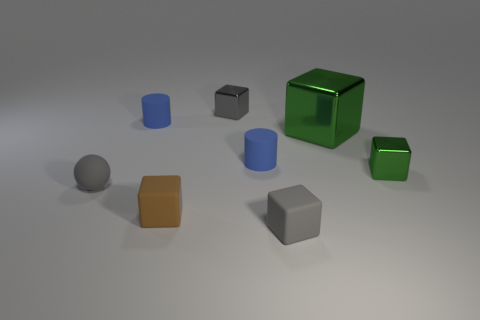Subtract all brown blocks. How many blocks are left? 4 Subtract all large metal blocks. How many blocks are left? 4 Subtract 1 blocks. How many blocks are left? 4 Add 1 large shiny cubes. How many objects exist? 9 Subtract all brown cubes. Subtract all red cylinders. How many cubes are left? 4 Subtract all cylinders. How many objects are left? 6 Subtract all large metal objects. Subtract all cylinders. How many objects are left? 5 Add 5 cylinders. How many cylinders are left? 7 Add 7 small gray cubes. How many small gray cubes exist? 9 Subtract 0 yellow cylinders. How many objects are left? 8 